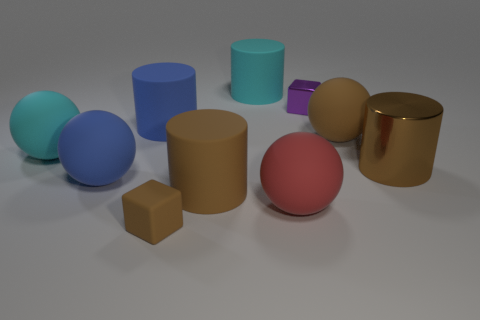Subtract all cyan cylinders. How many cylinders are left? 3 Subtract all blue cylinders. How many cylinders are left? 3 Subtract 1 cubes. How many cubes are left? 1 Add 4 big cyan matte things. How many big cyan matte things exist? 6 Subtract 1 blue cylinders. How many objects are left? 9 Subtract all cylinders. How many objects are left? 6 Subtract all cyan balls. Subtract all red cylinders. How many balls are left? 3 Subtract all brown balls. How many gray cylinders are left? 0 Subtract all cyan shiny cylinders. Subtract all brown objects. How many objects are left? 6 Add 5 small blocks. How many small blocks are left? 7 